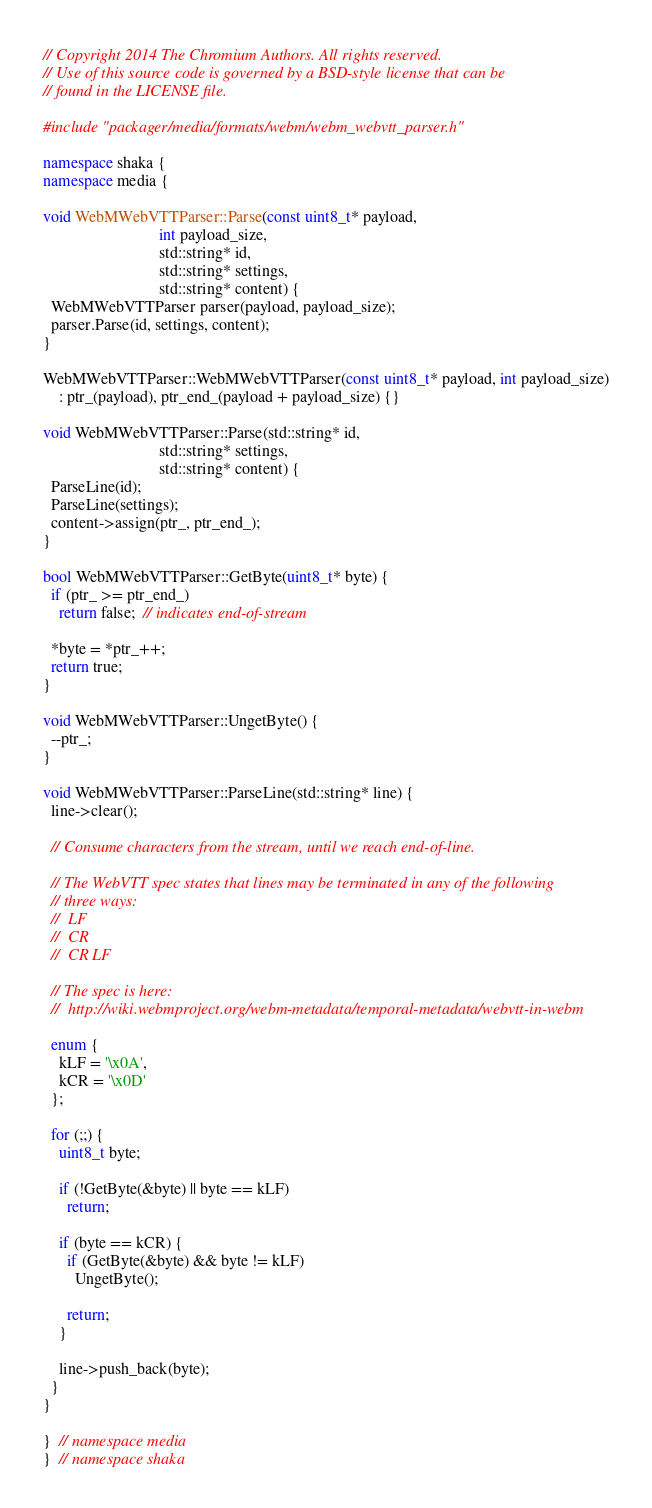Convert code to text. <code><loc_0><loc_0><loc_500><loc_500><_C++_>// Copyright 2014 The Chromium Authors. All rights reserved.
// Use of this source code is governed by a BSD-style license that can be
// found in the LICENSE file.

#include "packager/media/formats/webm/webm_webvtt_parser.h"

namespace shaka {
namespace media {

void WebMWebVTTParser::Parse(const uint8_t* payload,
                             int payload_size,
                             std::string* id,
                             std::string* settings,
                             std::string* content) {
  WebMWebVTTParser parser(payload, payload_size);
  parser.Parse(id, settings, content);
}

WebMWebVTTParser::WebMWebVTTParser(const uint8_t* payload, int payload_size)
    : ptr_(payload), ptr_end_(payload + payload_size) {}

void WebMWebVTTParser::Parse(std::string* id,
                             std::string* settings,
                             std::string* content) {
  ParseLine(id);
  ParseLine(settings);
  content->assign(ptr_, ptr_end_);
}

bool WebMWebVTTParser::GetByte(uint8_t* byte) {
  if (ptr_ >= ptr_end_)
    return false;  // indicates end-of-stream

  *byte = *ptr_++;
  return true;
}

void WebMWebVTTParser::UngetByte() {
  --ptr_;
}

void WebMWebVTTParser::ParseLine(std::string* line) {
  line->clear();

  // Consume characters from the stream, until we reach end-of-line.

  // The WebVTT spec states that lines may be terminated in any of the following
  // three ways:
  //  LF
  //  CR
  //  CR LF

  // The spec is here:
  //  http://wiki.webmproject.org/webm-metadata/temporal-metadata/webvtt-in-webm

  enum {
    kLF = '\x0A',
    kCR = '\x0D'
  };

  for (;;) {
    uint8_t byte;

    if (!GetByte(&byte) || byte == kLF)
      return;

    if (byte == kCR) {
      if (GetByte(&byte) && byte != kLF)
        UngetByte();

      return;
    }

    line->push_back(byte);
  }
}

}  // namespace media
}  // namespace shaka
</code> 